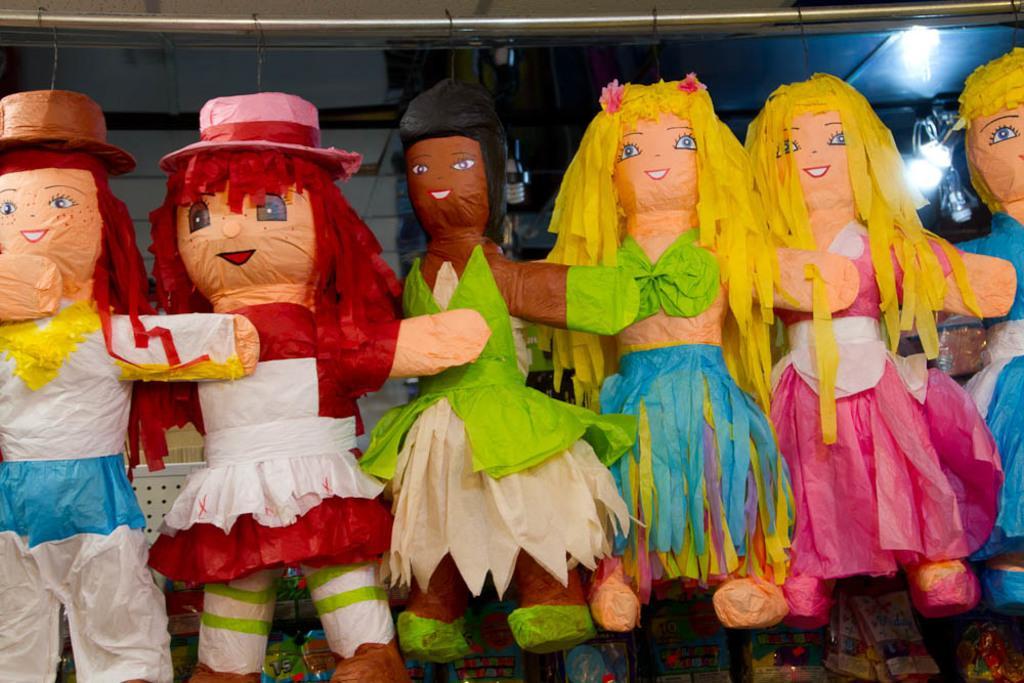Can you describe this image briefly? These are the dolls made up of paper, on the right side there are lights at the top. 